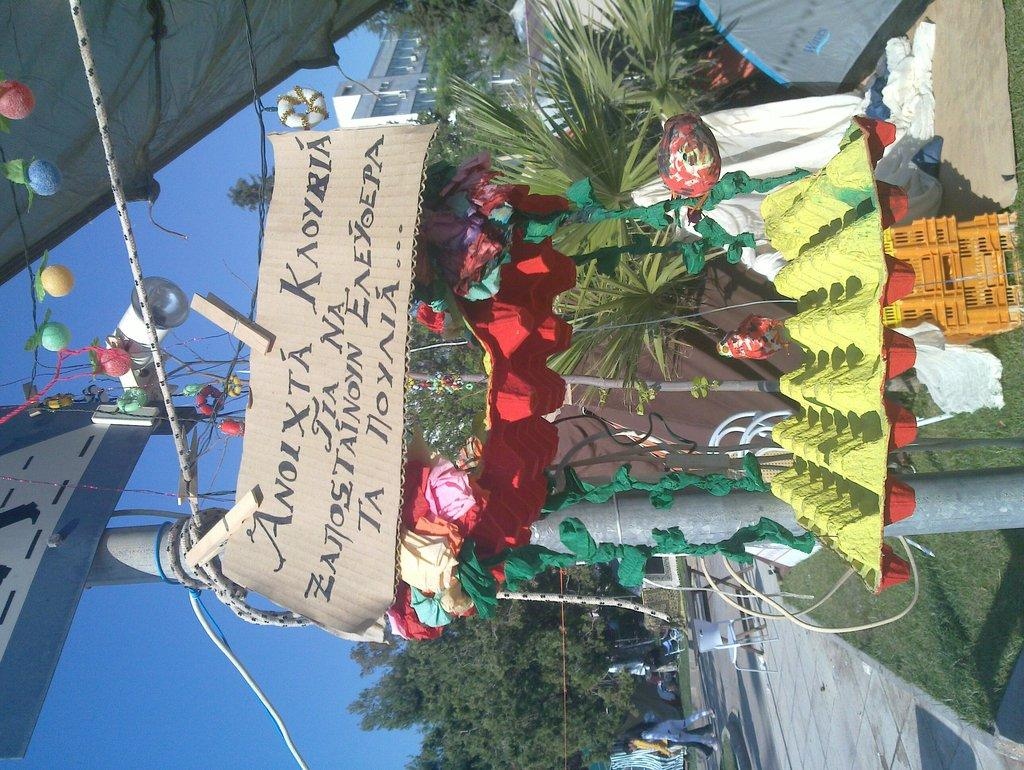Where was the image taken? The image was clicked outside. What can be seen on the left side of the image? There is sky visible on the left side of the image. What is present at the bottom of the image? There are trees and chairs at the bottom of the image. What is located in the middle of the image? There are plants in the middle of the image. How many frogs are sitting on the chairs in the image? There are no frogs present in the image; it only features trees, chairs, and plants. What emotion is being expressed by the plants in the image? Plants do not express emotions, so this question cannot be answered. 